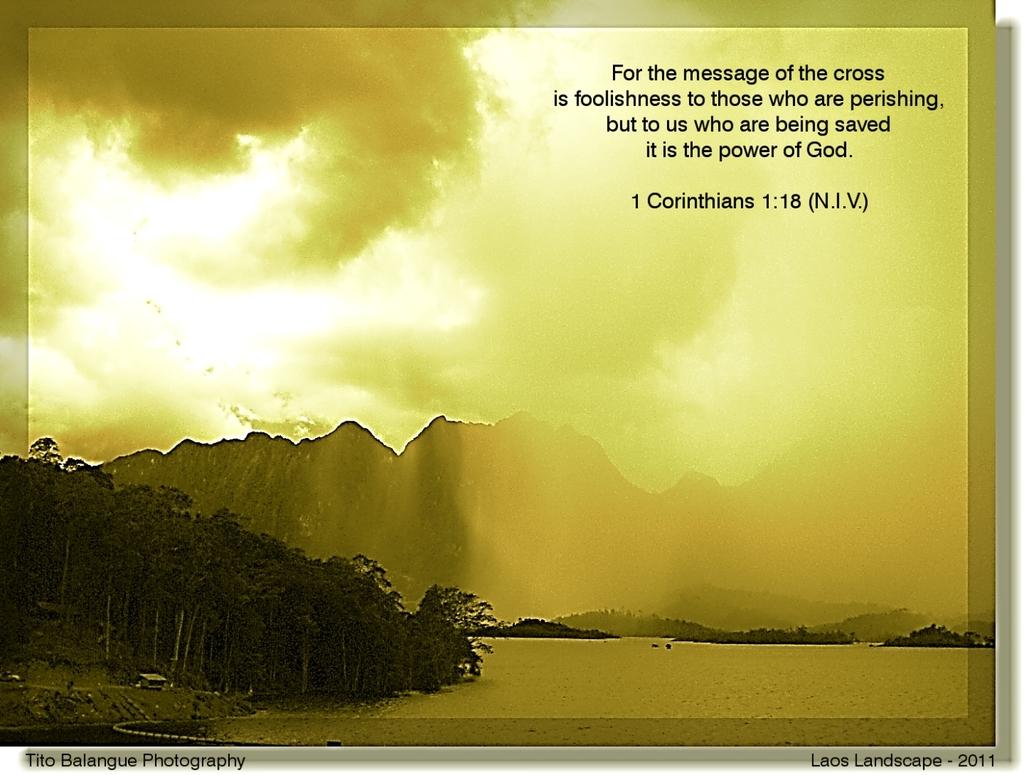What bible verse is this?
Make the answer very short. 1 corinthians 1:18. What is the last line of the bible verse?
Provide a short and direct response. It is the power of god. 